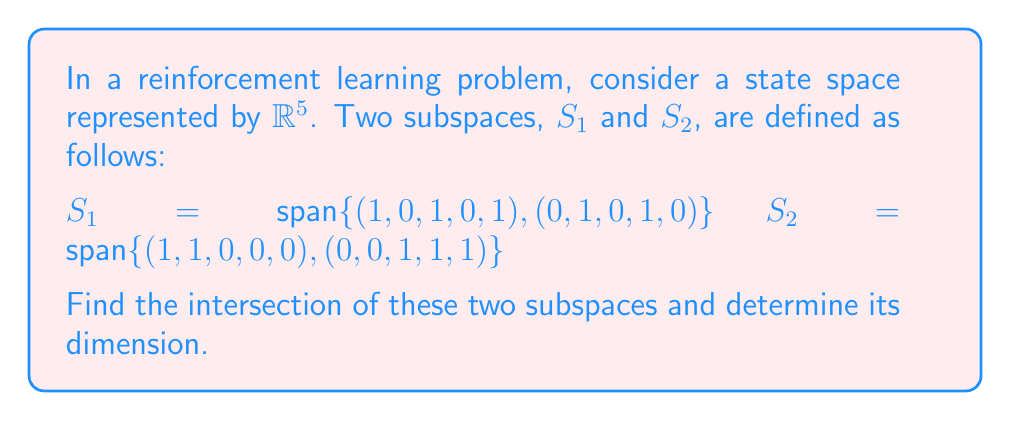Could you help me with this problem? To find the intersection of the two subspaces, we need to follow these steps:

1) First, we need to find the basis vectors for each subspace:
   $S_1: \mathbf{v_1} = (1,0,1,0,1), \mathbf{v_2} = (0,1,0,1,0)$
   $S_2: \mathbf{w_1} = (1,1,0,0,0), \mathbf{w_2} = (0,0,1,1,1)$

2) Any vector in the intersection must be a linear combination of vectors from both $S_1$ and $S_2$. Let's set up an equation:

   $a\mathbf{v_1} + b\mathbf{v_2} = c\mathbf{w_1} + d\mathbf{w_2}$

3) Expanding this equation:

   $a(1,0,1,0,1) + b(0,1,0,1,0) = c(1,1,0,0,0) + d(0,0,1,1,1)$

4) This gives us a system of equations:

   $a = c$
   $b = c$
   $a = d$
   $b = d$
   $a + d = d$

5) From these equations, we can deduce:

   $a = b = c = d$

6) This means that any vector in the intersection must be of the form:

   $a[(1,0,1,0,1) + (0,1,0,1,0)] = a(1,1,1,1,1)$

7) Therefore, the intersection is the span of the vector $(1,1,1,1,1)$:

   $S_1 \cap S_2 = \text{span}\{(1,1,1,1,1)\}$

8) The dimension of this intersection is 1, as it's spanned by a single vector.
Answer: $S_1 \cap S_2 = \text{span}\{(1,1,1,1,1)\}$, dimension = 1 